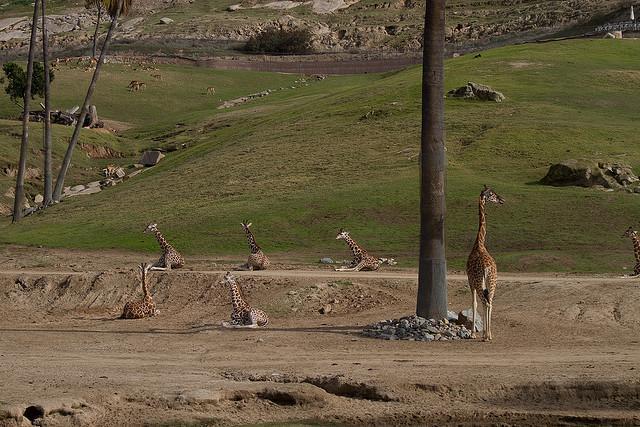How many giraffes are in the picture?
Give a very brief answer. 6. How many giraffes are in this photo?
Give a very brief answer. 6. 